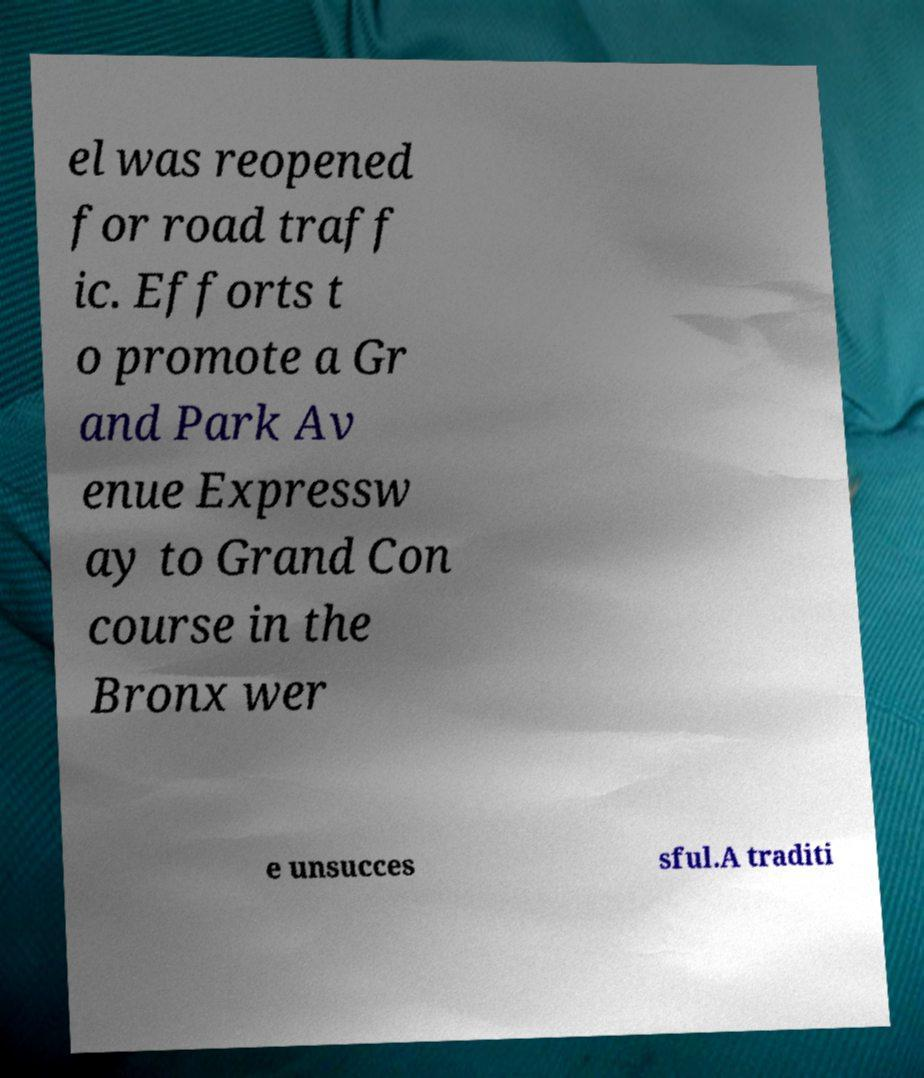Please identify and transcribe the text found in this image. el was reopened for road traff ic. Efforts t o promote a Gr and Park Av enue Expressw ay to Grand Con course in the Bronx wer e unsucces sful.A traditi 